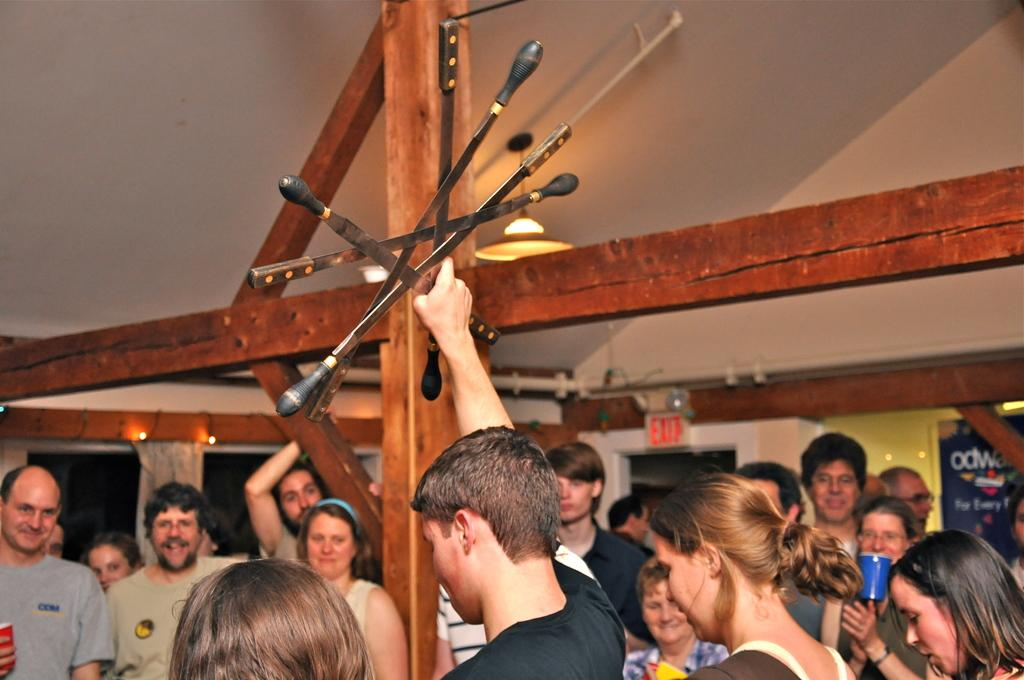How many people are in the image? There are people in the image, but the exact number is not specified. What is the person holding in the image? A person is holding objects in the image. What type of objects are the wooden sticks? There are wooden sticks in the image. What is the purpose of the sign board in the image? The purpose of the sign board in the image is not specified. What can be seen on the wall in the background of the image? There is a poster on the wall in the background of the image. What type of root can be seen growing from the person's head in the image? There is no root growing from anyone's head in the image. What kind of offer is being made by the person holding objects in the image? The facts do not mention any offer being made by the person holding objects in the image. 